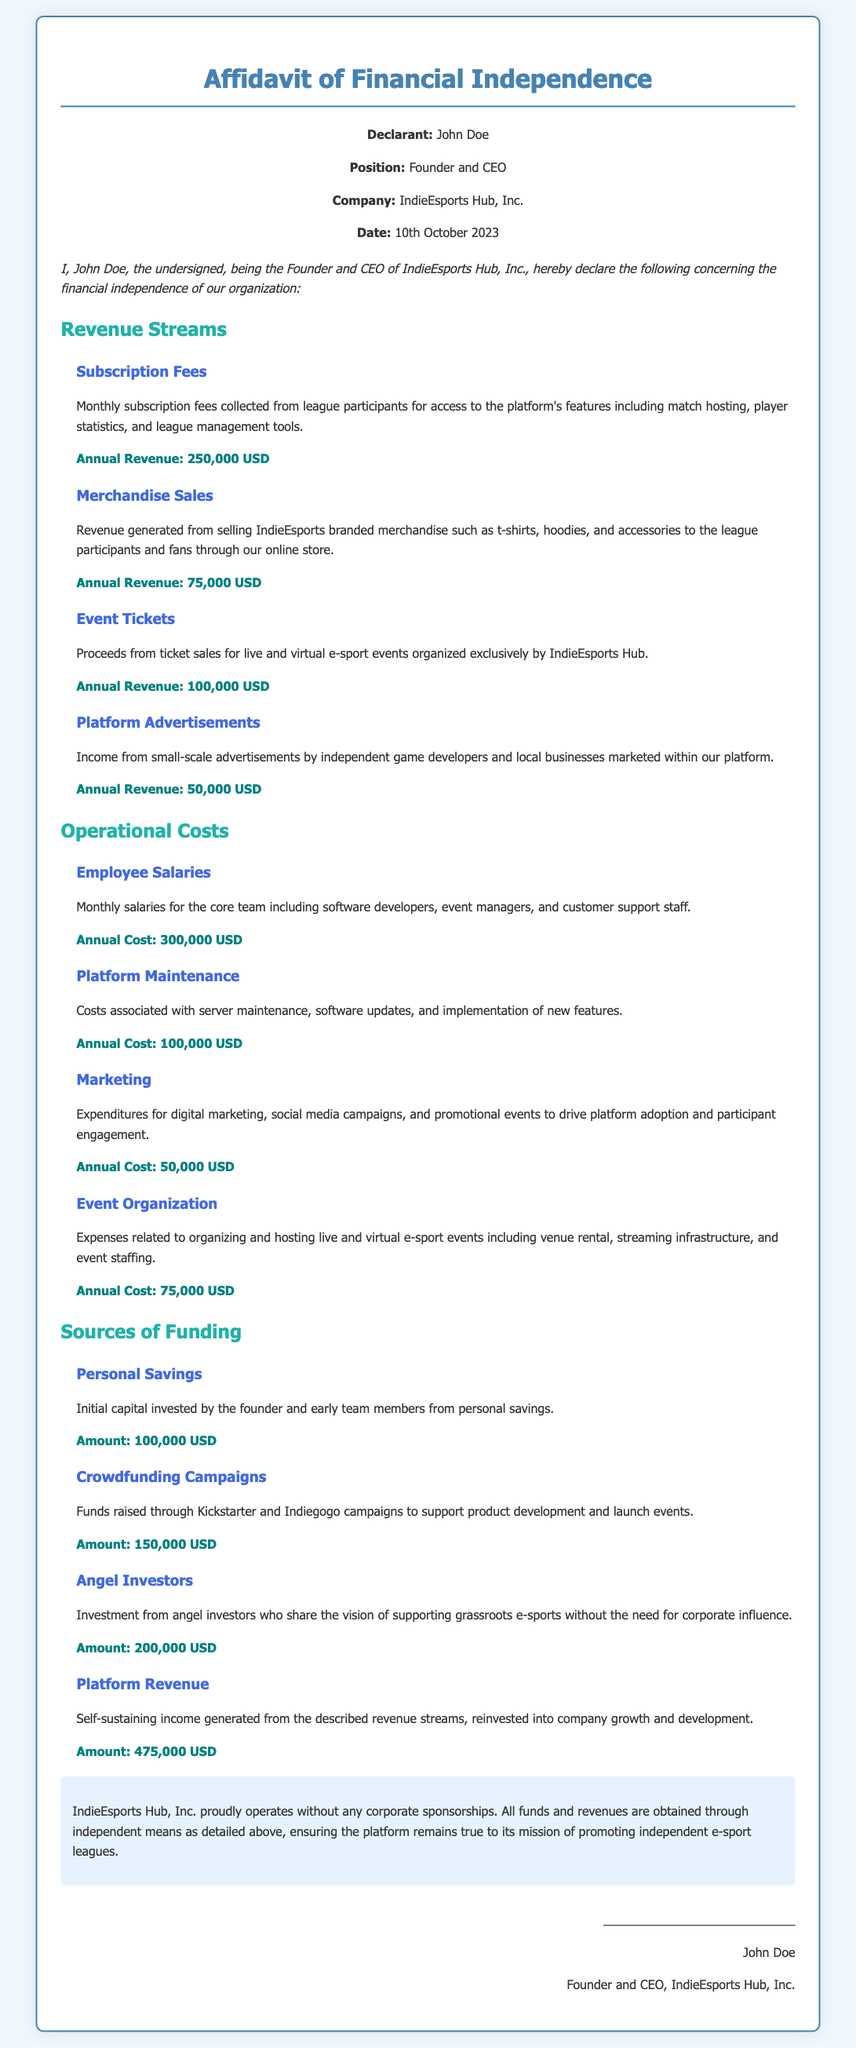what is the total annual revenue from subscription fees? The document states that the annual revenue from subscription fees is 250,000 USD.
Answer: 250,000 USD how much revenue is generated from merchandise sales? The document mentions that revenue generated from merchandise sales is 75,000 USD.
Answer: 75,000 USD what is the annual cost for employee salaries? The document indicates that the annual cost for employee salaries is 300,000 USD.
Answer: 300,000 USD how much funding is obtained from angel investors? The document specifies that the amount raised from angel investors is 200,000 USD.
Answer: 200,000 USD what are the total operational costs? The total operational costs can be calculated from the sum of all costs detailed in the document. These costs total 525,000 USD.
Answer: 525,000 USD what is the name of the company? The name of the company mentioned in the document is IndieEsports Hub, Inc.
Answer: IndieEsports Hub, Inc what is the position of the declarant? The document states that the position of the declarant is Founder and CEO.
Answer: Founder and CEO does the company have any corporate sponsorships? The document clearly states that IndieEsports Hub, Inc. operates without any corporate sponsorships.
Answer: No what is the date of the affidavit? The date when the affidavit was signed is listed as 10th October 2023.
Answer: 10th October 2023 